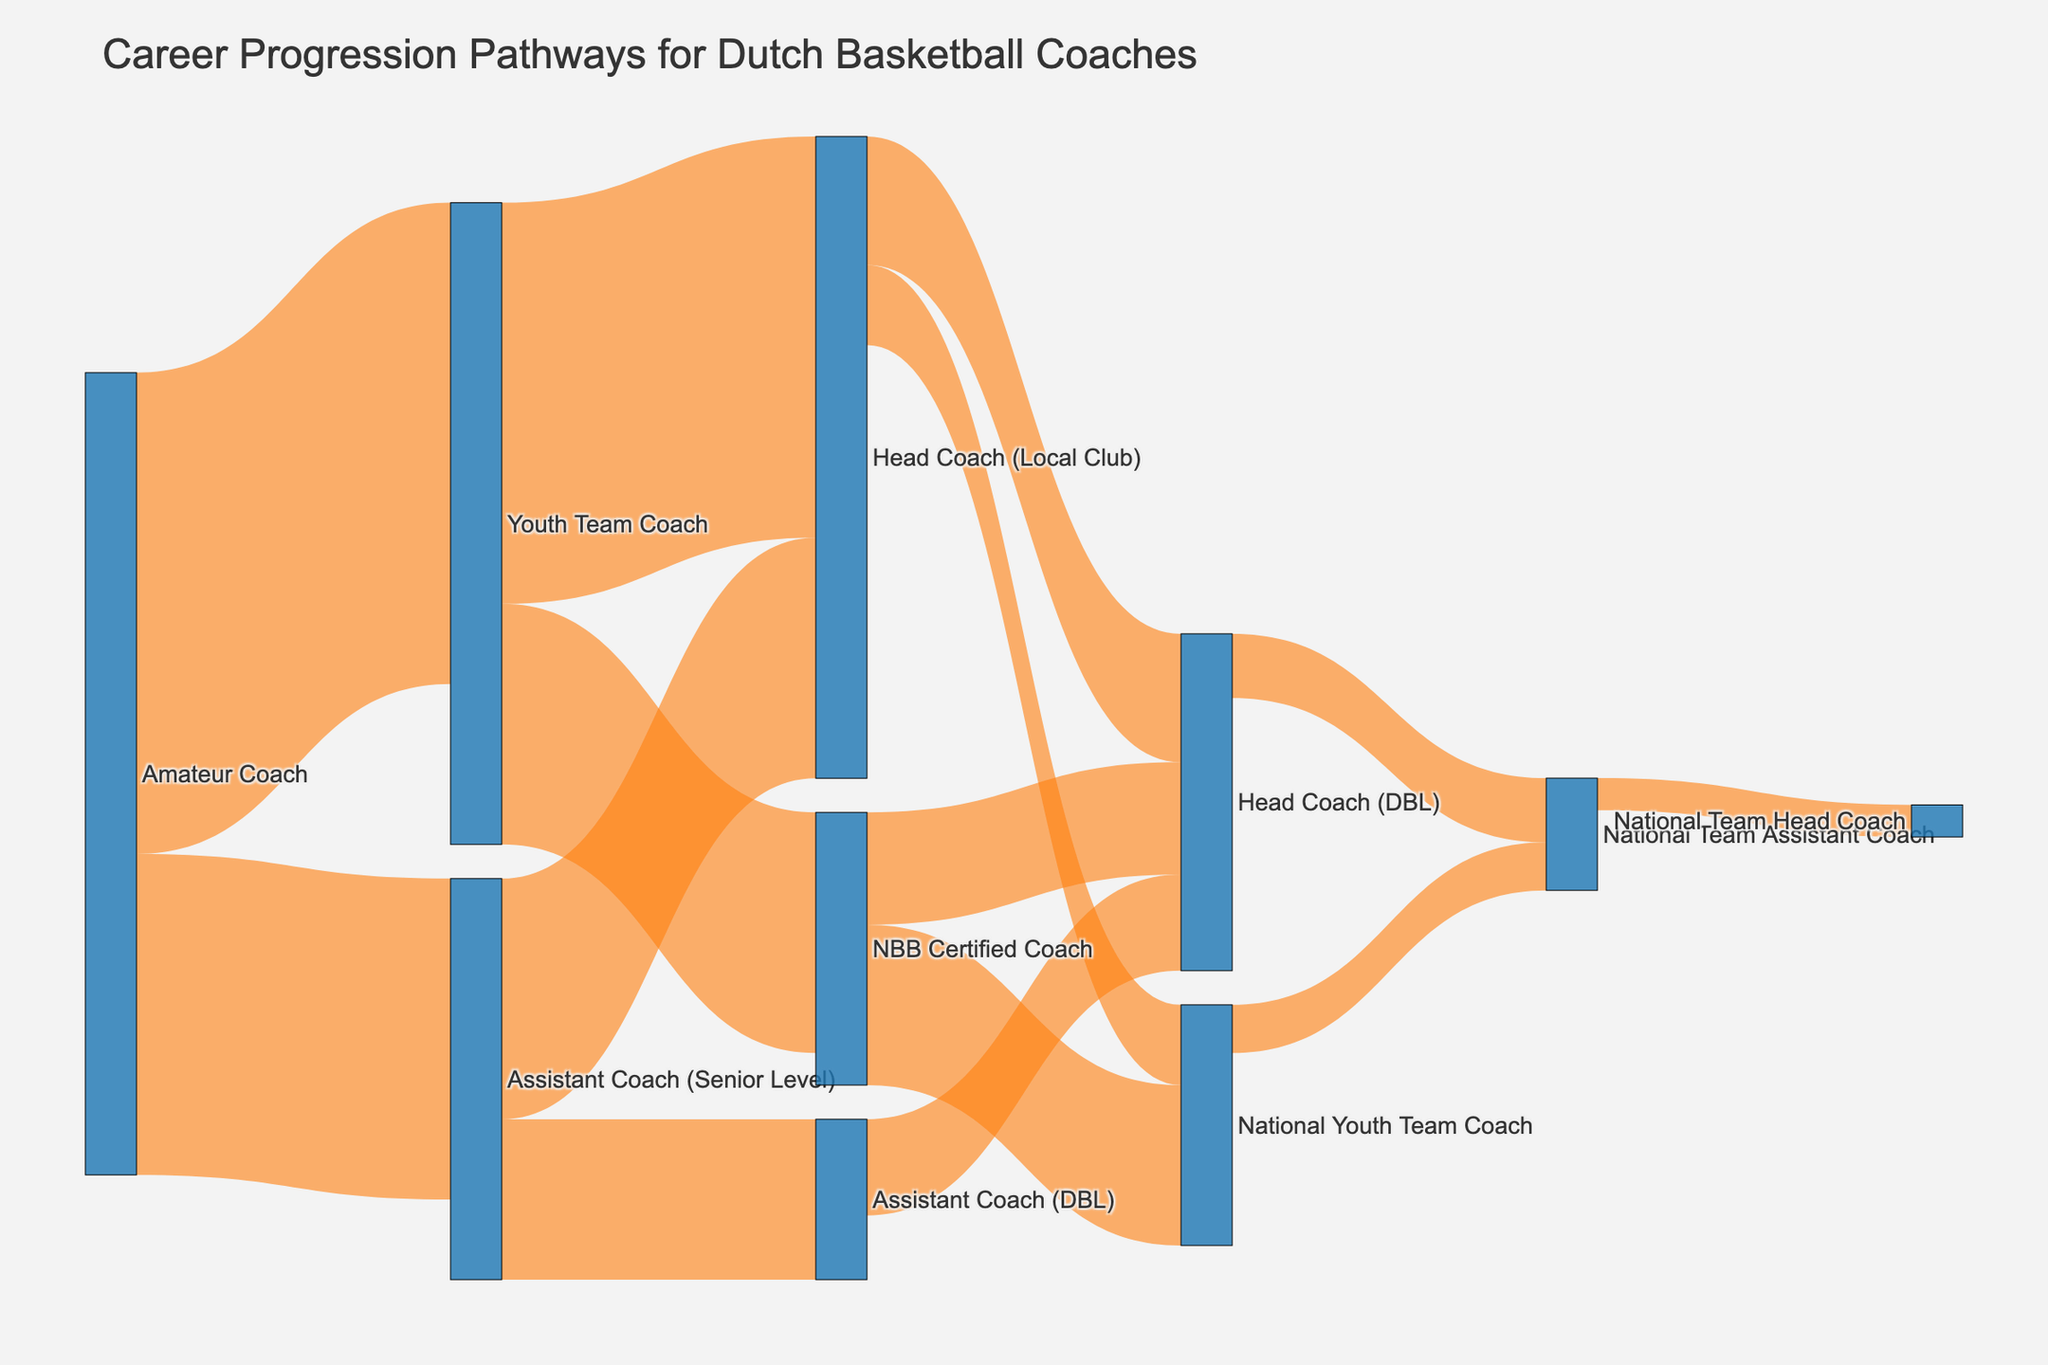What is the title of the chart? The title of the chart is located at the top of the figure, which contains the main description of what the figure represents.
Answer: Career Progression Pathways for Dutch Basketball Coaches What is the most common initial position for Dutch basketball coaches according to the chart? By looking at the starting points of the flows, we can see which position has the most outgoing connections. The "Amateur Coach" position has the highest number of starting flows.
Answer: Amateur Coach How many coaches transition from "Amateur Coach" to "Youth Team Coach"? Track the flow from "Amateur Coach" to "Youth Team Coach" and read the number associated with it.
Answer: 30 Which position has more outgoing flows, "Youth Team Coach" or "Assistant Coach (Senior Level)"? Compare the outgoing flows from both "Youth Team Coach" and "Assistant Coach (Senior Level)" by counting the number of transitions each position has. "Youth Team Coach" has 2, and "Assistant Coach (Senior Level)" has 2 as well, therefore neither has more than the other.
Answer: Neither What is the total number of coaches progressing from "NBB Certified Coach" to all other positions? Sum the values of the flows going out from "NBB Certified Coach". There are two flows: 10 (to "National Youth Team Coach") and 7 (to "Head Coach (DBL)"). 10 + 7 = 17.
Answer: 17 Which pathway has the smallest number of coaches? Look for the flow with the smallest value on the diagram. The pathway from "National Team Assistant Coach" to "National Team Head Coach" has the smallest value, which is 2.
Answer: National Team Assistant Coach to National Team Head Coach How many coaches in total transition to the "National Youth Team Coach" position? Sum the values of all the flows that end at "National Youth Team Coach". There are two flows: 5 (from "Head Coach (Local Club)") and 10 (from "NBB Certified Coach"). 5 + 10 = 15.
Answer: 15 How does the number of coaches transitioning from "Assistant Coach (DBL)" to "Head Coach (DBL)" compare to those transitioning from "NBB Certified Coach" to "Head Coach (DBL)"? Compare the values of the flows: 6 coaches transition from "Assistant Coach (DBL)" to "Head Coach (DBL)", while 7 coaches transition from "NBB Certified Coach" to "Head Coach (DBL)". 6 < 7.
Answer: 6 < 7 What is the combined number of coaches that reach "Head Coach (DBL)" from any starting position? Sum all the values that end at "Head Coach (DBL)". These are: 8 (from "Head Coach (Local Club)"), 7 (from "NBB Certified Coach"), and 6 (from "Assistant Coach (DBL)"). 8 + 7 + 6 = 21.
Answer: 21 From which position do more coaches end up in "National Team Assistant Coach", "Head Coach (DBL)" or "National Team Assistant Coach"? Compare the values of the flows that lead to "National Team Assistant Coach": 4 (from "Head Coach (DBL)") and 3 (from "National Youth Team Coach"). 4 > 3.
Answer: Head Coach (DBL) 